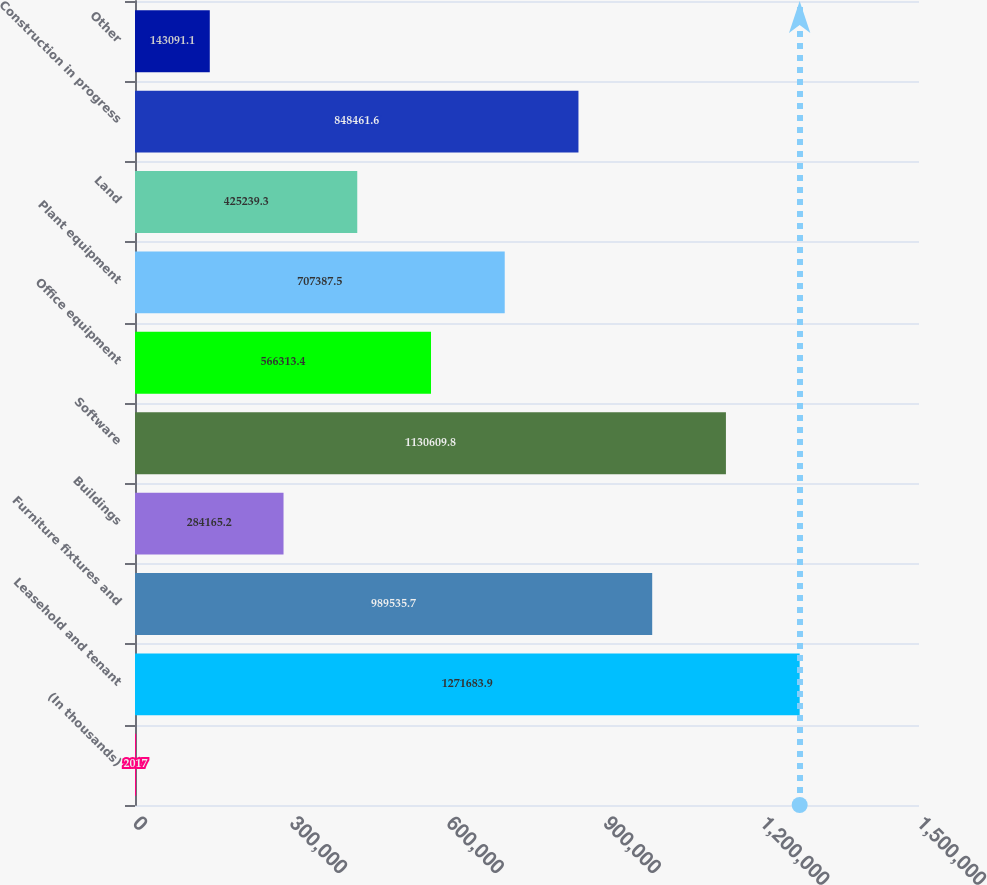Convert chart to OTSL. <chart><loc_0><loc_0><loc_500><loc_500><bar_chart><fcel>(In thousands)<fcel>Leasehold and tenant<fcel>Furniture fixtures and<fcel>Buildings<fcel>Software<fcel>Office equipment<fcel>Plant equipment<fcel>Land<fcel>Construction in progress<fcel>Other<nl><fcel>2017<fcel>1.27168e+06<fcel>989536<fcel>284165<fcel>1.13061e+06<fcel>566313<fcel>707388<fcel>425239<fcel>848462<fcel>143091<nl></chart> 